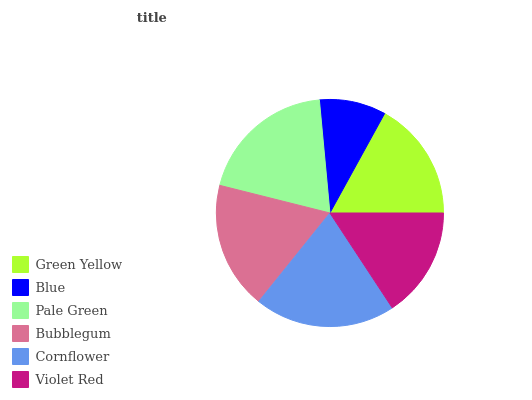Is Blue the minimum?
Answer yes or no. Yes. Is Cornflower the maximum?
Answer yes or no. Yes. Is Pale Green the minimum?
Answer yes or no. No. Is Pale Green the maximum?
Answer yes or no. No. Is Pale Green greater than Blue?
Answer yes or no. Yes. Is Blue less than Pale Green?
Answer yes or no. Yes. Is Blue greater than Pale Green?
Answer yes or no. No. Is Pale Green less than Blue?
Answer yes or no. No. Is Bubblegum the high median?
Answer yes or no. Yes. Is Green Yellow the low median?
Answer yes or no. Yes. Is Pale Green the high median?
Answer yes or no. No. Is Blue the low median?
Answer yes or no. No. 